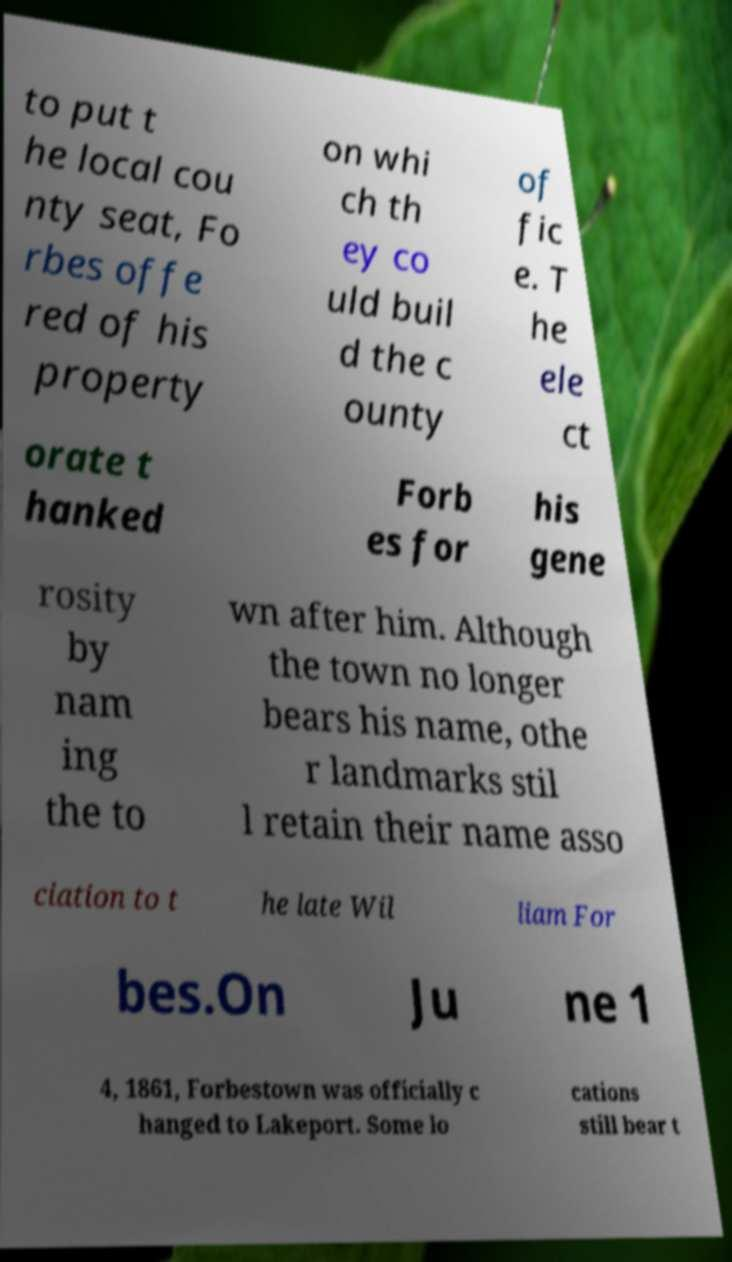Could you assist in decoding the text presented in this image and type it out clearly? to put t he local cou nty seat, Fo rbes offe red of his property on whi ch th ey co uld buil d the c ounty of fic e. T he ele ct orate t hanked Forb es for his gene rosity by nam ing the to wn after him. Although the town no longer bears his name, othe r landmarks stil l retain their name asso ciation to t he late Wil liam For bes.On Ju ne 1 4, 1861, Forbestown was officially c hanged to Lakeport. Some lo cations still bear t 